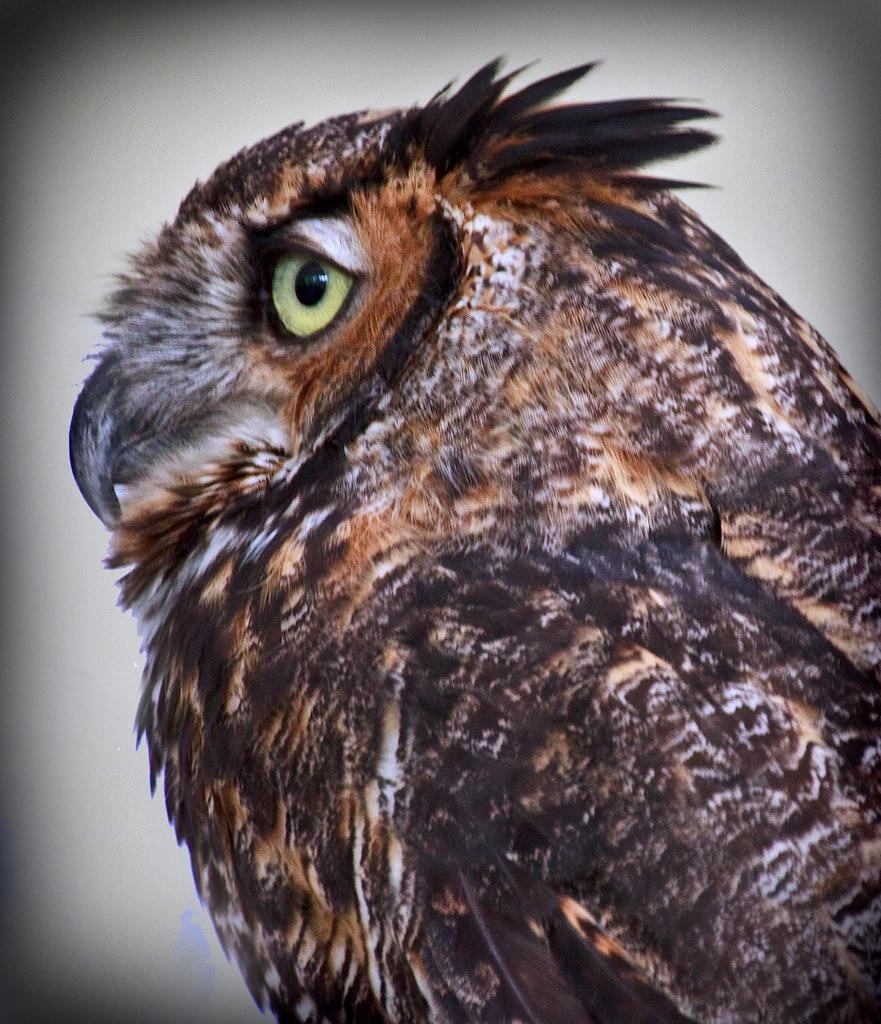What type of animal is in the image? There is an owl in the image. What color is the background of the image? The background of the image is white. Who is the father of the owl in the image? Owls do not have fathers in the same way humans do; they have parents, but we cannot determine the gender of the owl in the image. Can you see the owl giving a kiss in the image? There is no indication of the owl giving a kiss in the image. 